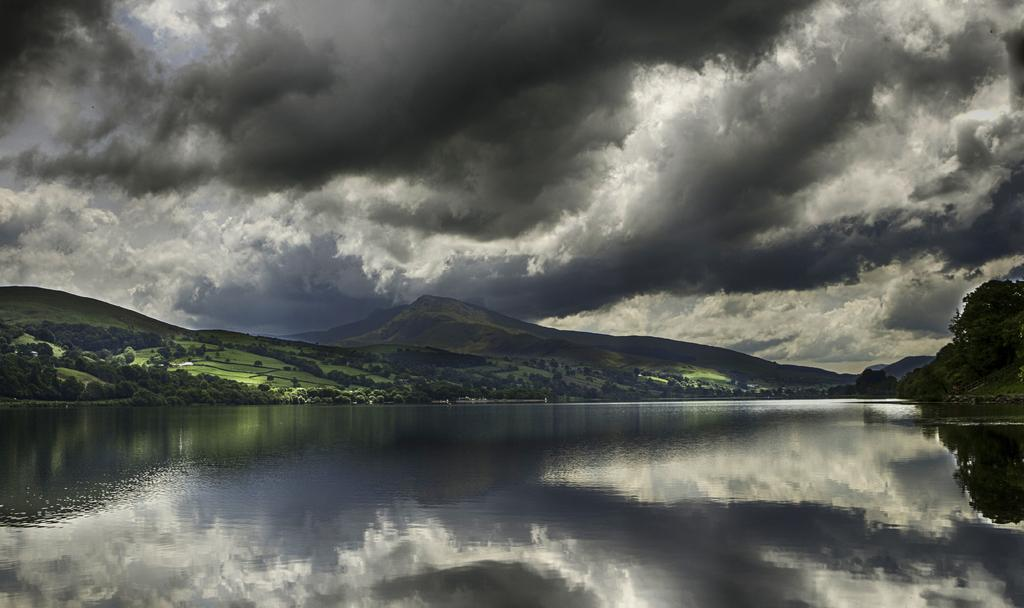What is the primary element visible in the image? There is water in the image. What type of terrain can be seen in the image? There are hills with a grass surface in the image. What kind of vegetation is present on the hills? Plants and trees are present on the hills. What is visible in the sky in the image? The sky is visible in the image, and clouds are present. Can you tell me how many quinces are growing on the trees in the image? There is no mention of quinces in the image; the trees present are not specified as quince trees. 